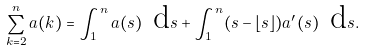Convert formula to latex. <formula><loc_0><loc_0><loc_500><loc_500>\sum _ { k = 2 } ^ { n } a ( k ) = \int _ { 1 } ^ { n } a ( s ) \ \text {d} s + \int _ { 1 } ^ { n } ( s - \lfloor s \rfloor ) a ^ { \prime } ( s ) \ \text {d} s .</formula> 